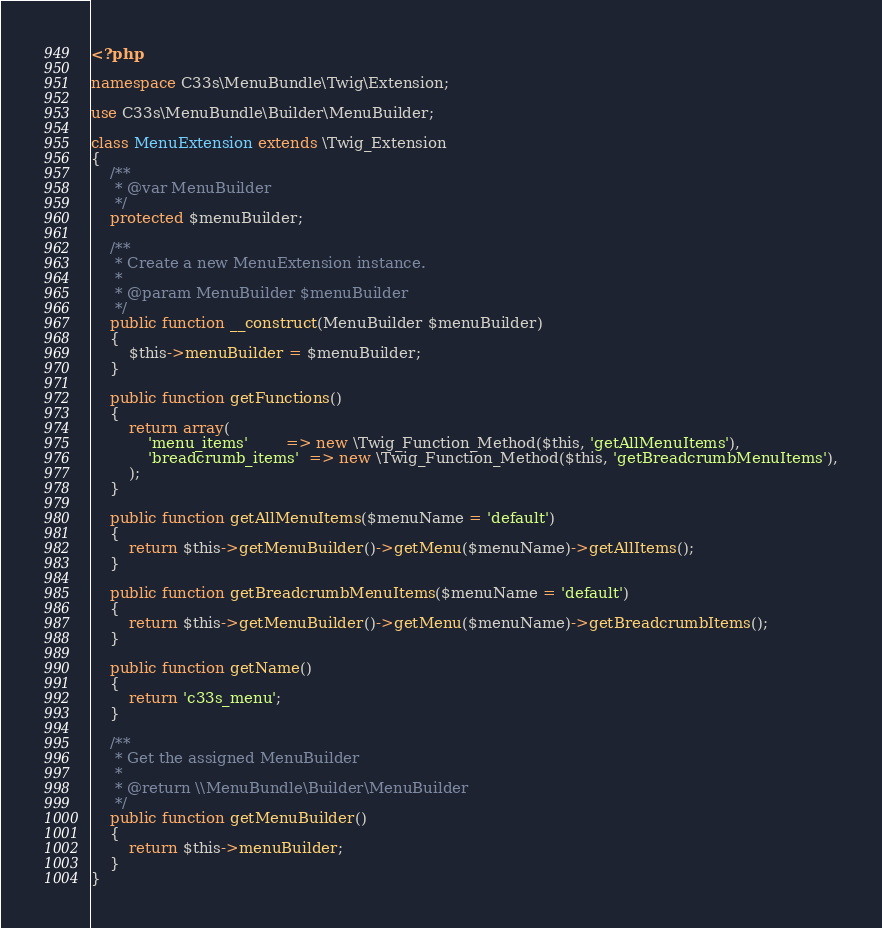Convert code to text. <code><loc_0><loc_0><loc_500><loc_500><_PHP_><?php

namespace C33s\MenuBundle\Twig\Extension;

use C33s\MenuBundle\Builder\MenuBuilder;

class MenuExtension extends \Twig_Extension
{
    /**
     * @var MenuBuilder
     */
    protected $menuBuilder;
    
    /**
     * Create a new MenuExtension instance.
     *
     * @param MenuBuilder $menuBuilder
     */
    public function __construct(MenuBuilder $menuBuilder)
    {
        $this->menuBuilder = $menuBuilder;
    }
    
    public function getFunctions()
    {
        return array(
            'menu_items'        => new \Twig_Function_Method($this, 'getAllMenuItems'),
            'breadcrumb_items'  => new \Twig_Function_Method($this, 'getBreadcrumbMenuItems'),
        );
    }
    
    public function getAllMenuItems($menuName = 'default')
    {
        return $this->getMenuBuilder()->getMenu($menuName)->getAllItems();
    }
    
    public function getBreadcrumbMenuItems($menuName = 'default')
    {
        return $this->getMenuBuilder()->getMenu($menuName)->getBreadcrumbItems();
    }
    
    public function getName()
    {
        return 'c33s_menu';
    }
    
    /**
     * Get the assigned MenuBuilder
     *
     * @return \\MenuBundle\Builder\MenuBuilder
     */
    public function getMenuBuilder()
    {
        return $this->menuBuilder;
    }
}
</code> 